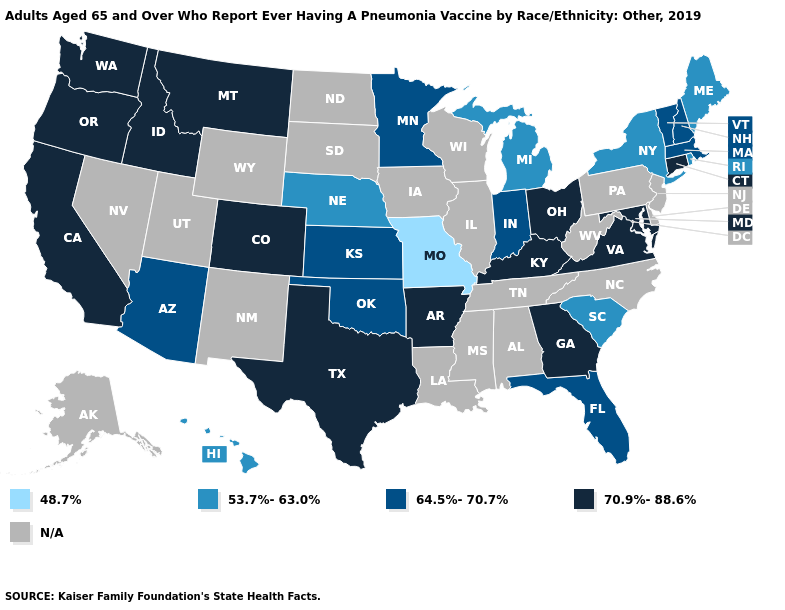Name the states that have a value in the range 70.9%-88.6%?
Be succinct. Arkansas, California, Colorado, Connecticut, Georgia, Idaho, Kentucky, Maryland, Montana, Ohio, Oregon, Texas, Virginia, Washington. Does Connecticut have the lowest value in the Northeast?
Write a very short answer. No. What is the value of Oklahoma?
Concise answer only. 64.5%-70.7%. What is the lowest value in states that border Tennessee?
Keep it brief. 48.7%. What is the value of Louisiana?
Write a very short answer. N/A. Name the states that have a value in the range N/A?
Give a very brief answer. Alabama, Alaska, Delaware, Illinois, Iowa, Louisiana, Mississippi, Nevada, New Jersey, New Mexico, North Carolina, North Dakota, Pennsylvania, South Dakota, Tennessee, Utah, West Virginia, Wisconsin, Wyoming. What is the lowest value in the USA?
Give a very brief answer. 48.7%. Is the legend a continuous bar?
Give a very brief answer. No. What is the value of Ohio?
Be succinct. 70.9%-88.6%. Name the states that have a value in the range N/A?
Give a very brief answer. Alabama, Alaska, Delaware, Illinois, Iowa, Louisiana, Mississippi, Nevada, New Jersey, New Mexico, North Carolina, North Dakota, Pennsylvania, South Dakota, Tennessee, Utah, West Virginia, Wisconsin, Wyoming. Among the states that border Illinois , does Indiana have the lowest value?
Keep it brief. No. Name the states that have a value in the range 53.7%-63.0%?
Short answer required. Hawaii, Maine, Michigan, Nebraska, New York, Rhode Island, South Carolina. What is the value of Colorado?
Answer briefly. 70.9%-88.6%. Name the states that have a value in the range 70.9%-88.6%?
Short answer required. Arkansas, California, Colorado, Connecticut, Georgia, Idaho, Kentucky, Maryland, Montana, Ohio, Oregon, Texas, Virginia, Washington. What is the value of Idaho?
Keep it brief. 70.9%-88.6%. 